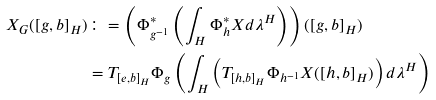Convert formula to latex. <formula><loc_0><loc_0><loc_500><loc_500>X _ { G } ( [ g , b ] _ { H } ) & \colon = \left ( \Phi _ { g ^ { - 1 } } ^ { * } \left ( \int _ { H } \Phi _ { h } ^ { * } X d \lambda ^ { H } \right ) \right ) ( [ g , b ] _ { H } ) \\ & = T _ { [ e , b ] _ { H } } \Phi _ { g } \left ( \int _ { H } \left ( T _ { [ h , b ] _ { H } } \Phi _ { h ^ { - 1 } } X ( [ h , b ] _ { H } ) \right ) d \lambda ^ { H } \right )</formula> 